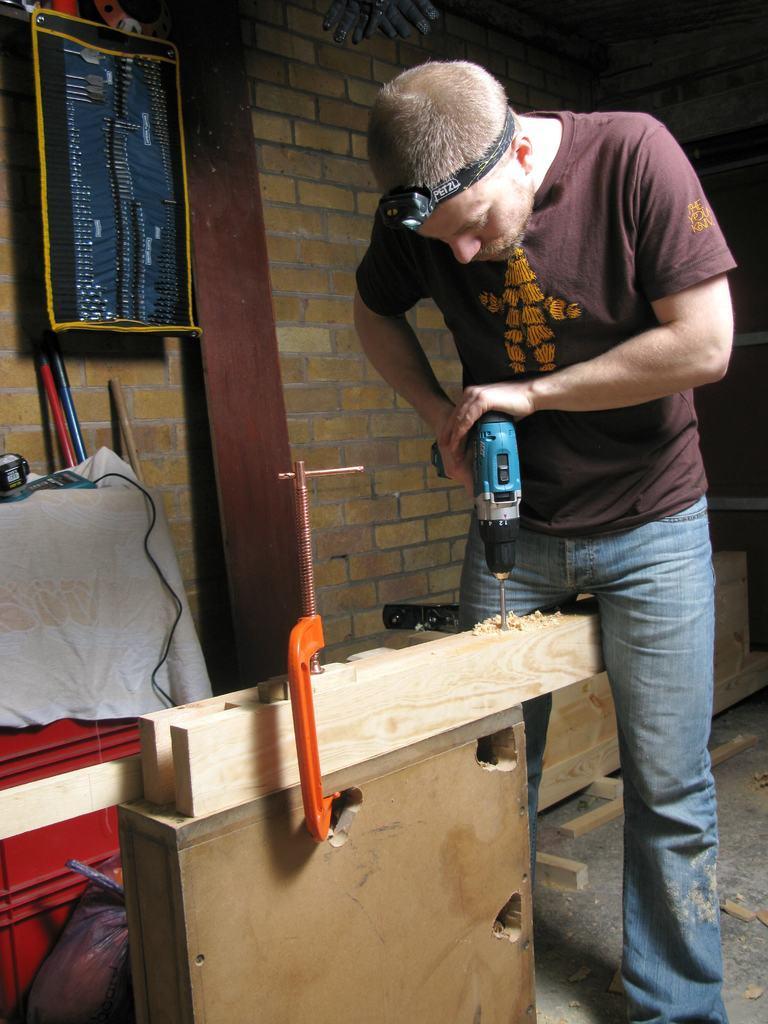Can you describe this image briefly? In the image we can see a man standing, wearing clothes and drill machine in the hands. Here we can see wooden sheets and cable wire. Here we can see cloth, brick wall, tool bag and the floor. 